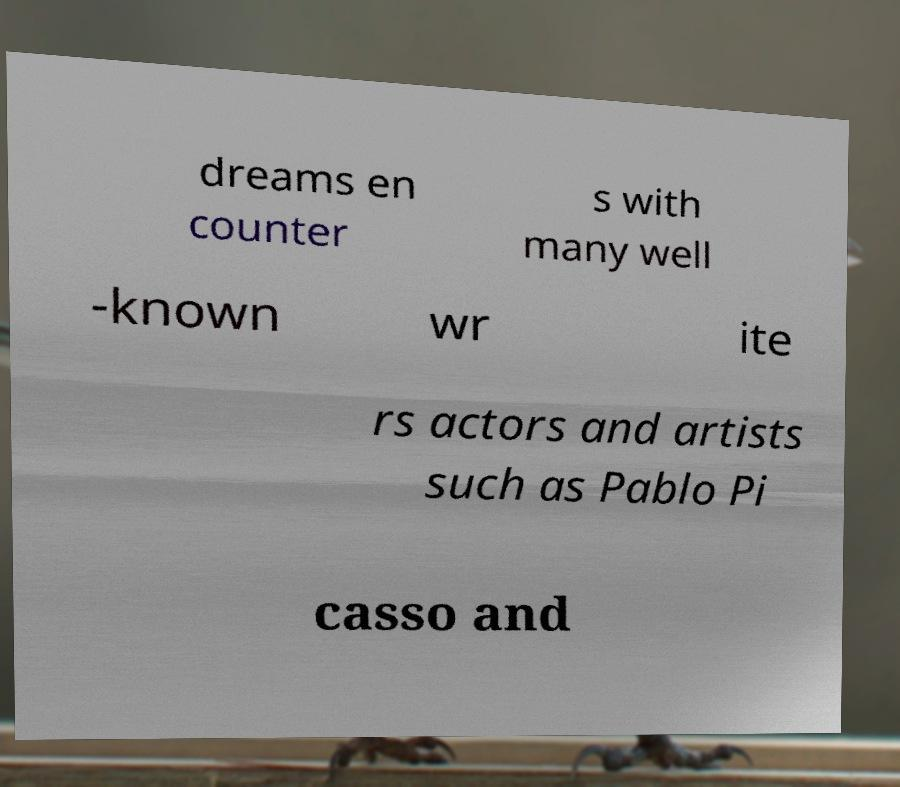I need the written content from this picture converted into text. Can you do that? dreams en counter s with many well -known wr ite rs actors and artists such as Pablo Pi casso and 